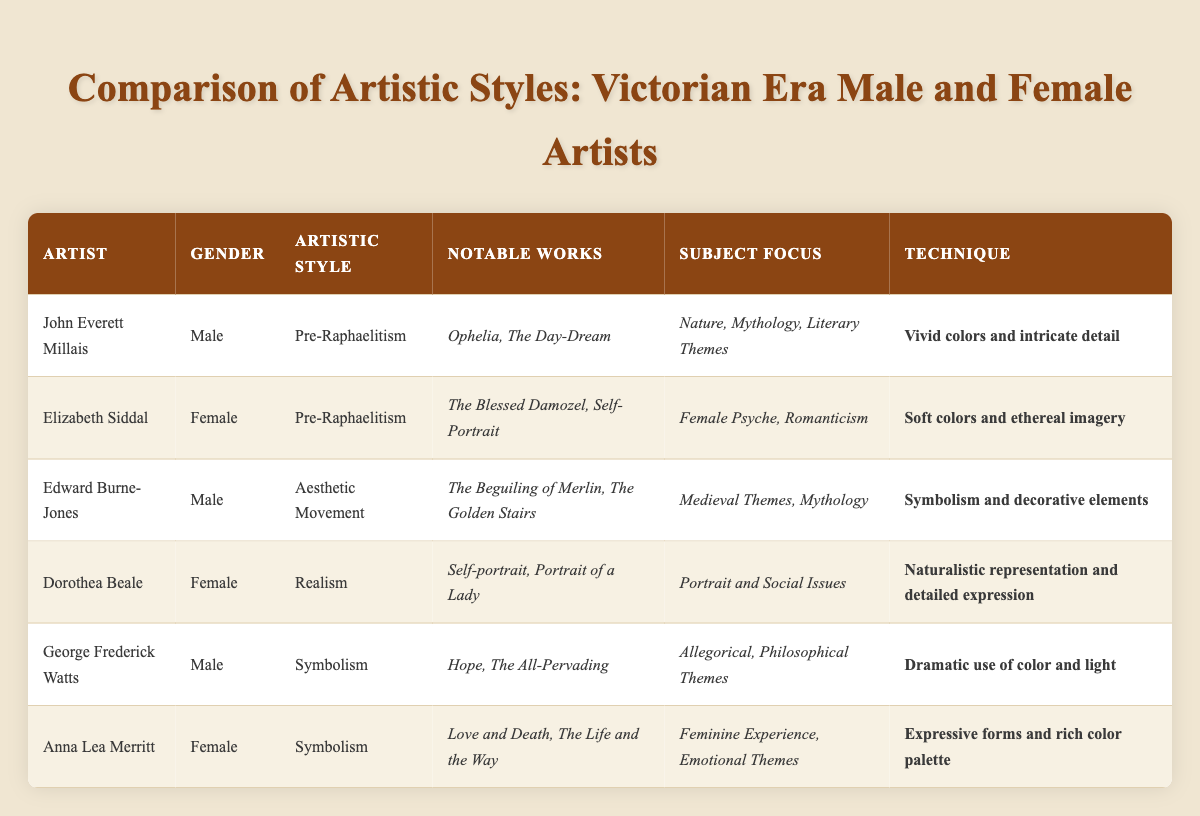What artistic style is associated with Elizabeth Siddal? The table lists Elizabeth Siddal under the artistic style of "Pre-Raphaelitism." This information can be found in the corresponding row for her in the table.
Answer: Pre-Raphaelitism How many notable works are listed for George Frederick Watts? According to the table, George Frederick Watts has two notable works listed: "Hope" and "The All-Pervading." These works can be found in the same row as his name.
Answer: 2 Which gender is attributed to the artist who focused on the "Female Psyche" and "Romanticism"? The table shows that the artist focusing on "Female Psyche" and "Romanticism" is Elizabeth Siddal, who is identified as female in the table.
Answer: Female Is Dorothea Beale known for her works in Symbolism? Reviewing the table, it identifies Dorothea Beale as an artist within the "Realism" style, not Symbolism. Hence, this statement is false.
Answer: No What is the primary technique used by Anna Lea Merritt, and how does it compare to John Everett Millais' technique? Anna Lea Merritt uses the technique of "Expressive forms and rich color palette," while John Everett Millais used "Vivid colors and intricate detail." This provides a contrast between Merritt's expressive approach and Millais' detailed style.
Answer: Different techniques How many artists in the table are associated with the artistic style of Symbolism? The table lists two artists in the Symbolism style: George Frederick Watts and Anna Lea Merritt. By counting these entries in the table, we find a total is obtained.
Answer: 2 Which artistic styles have representations from both male and female artists? The artistic styles that have both male and female representations, according to the table, are "Pre-Raphaelitism" and "Symbolism," as Millais and Siddal represent Pre-Raphaelitism while Watts and Merritt represent Symbolism.
Answer: Pre-Raphaelitism, Symbolism Which artist's notable works include "The Blessed Damozel"? The table clearly states that "The Blessed Damozel" is a notable work of Elizabeth Siddal, as per her row in the table.
Answer: Elizabeth Siddal 